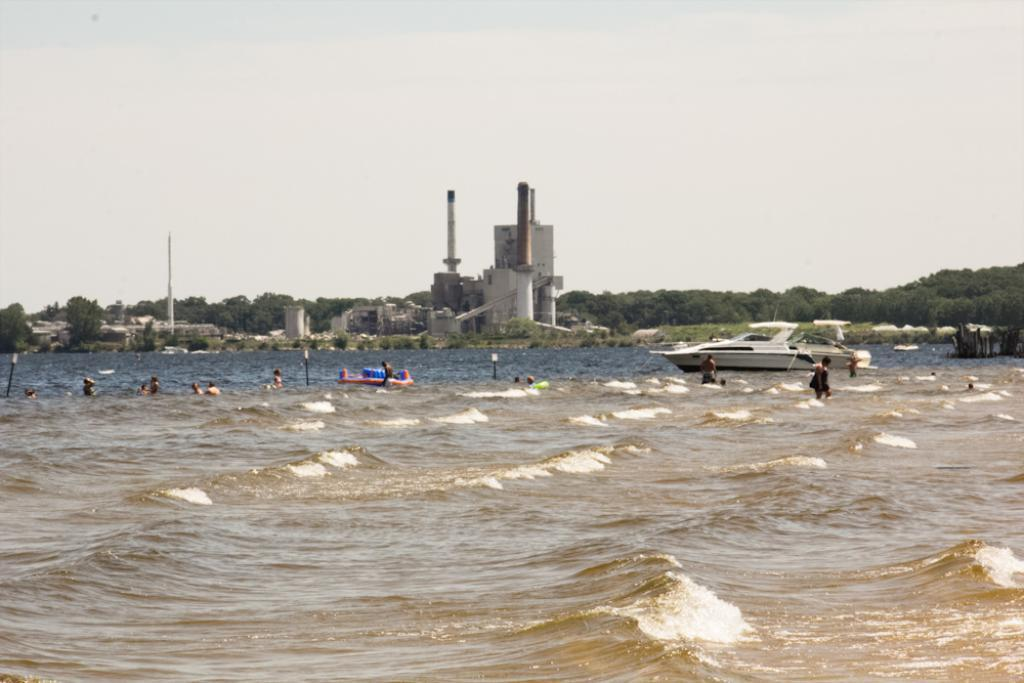What type of watercraft is in the water in the image? There is a boat in the water in the image. What other object is in the water besides the boat? There is a raft in the water. Are there any people in the image? Yes, there are people in the water. What structures can be seen in the image? There are buildings and a tower visible in the image. What type of vegetation is present in the image? There are trees in the image. How would you describe the sky in the image? The sky is cloudy in the image. How many cats are sitting on the back of the boat in the image? There are no cats present in the image. What type of knowledge is being shared among the people in the image? There is no indication of any knowledge being shared among the people in the image. 